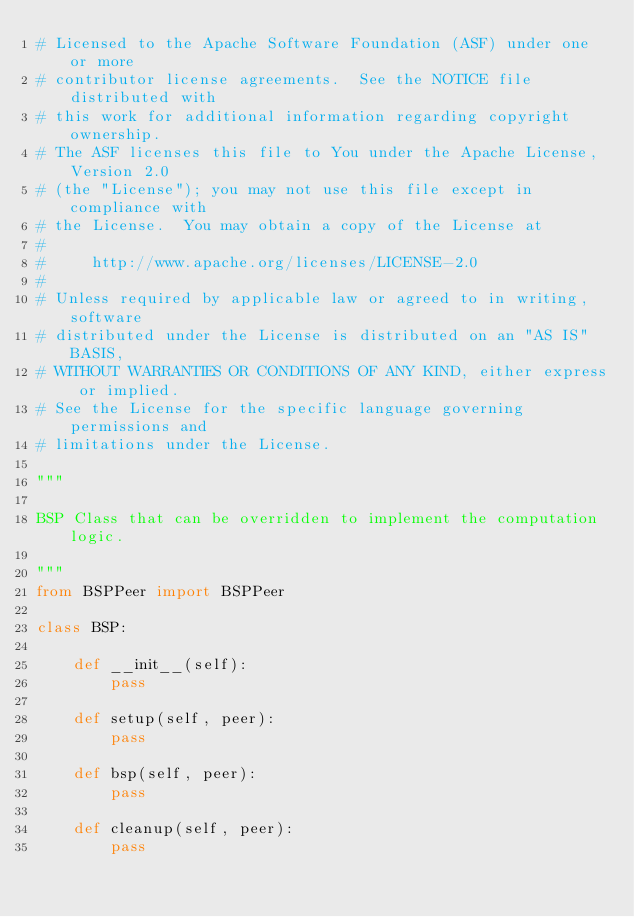Convert code to text. <code><loc_0><loc_0><loc_500><loc_500><_Python_># Licensed to the Apache Software Foundation (ASF) under one or more
# contributor license agreements.  See the NOTICE file distributed with
# this work for additional information regarding copyright ownership.
# The ASF licenses this file to You under the Apache License, Version 2.0
# (the "License"); you may not use this file except in compliance with
# the License.  You may obtain a copy of the License at
#
#     http://www.apache.org/licenses/LICENSE-2.0
#
# Unless required by applicable law or agreed to in writing, software
# distributed under the License is distributed on an "AS IS" BASIS,
# WITHOUT WARRANTIES OR CONDITIONS OF ANY KIND, either express or implied.
# See the License for the specific language governing permissions and
# limitations under the License.

"""

BSP Class that can be overridden to implement the computation logic.

"""
from BSPPeer import BSPPeer

class BSP:

    def __init__(self):
        pass

    def setup(self, peer):
        pass

    def bsp(self, peer):
        pass

    def cleanup(self, peer):
        pass</code> 